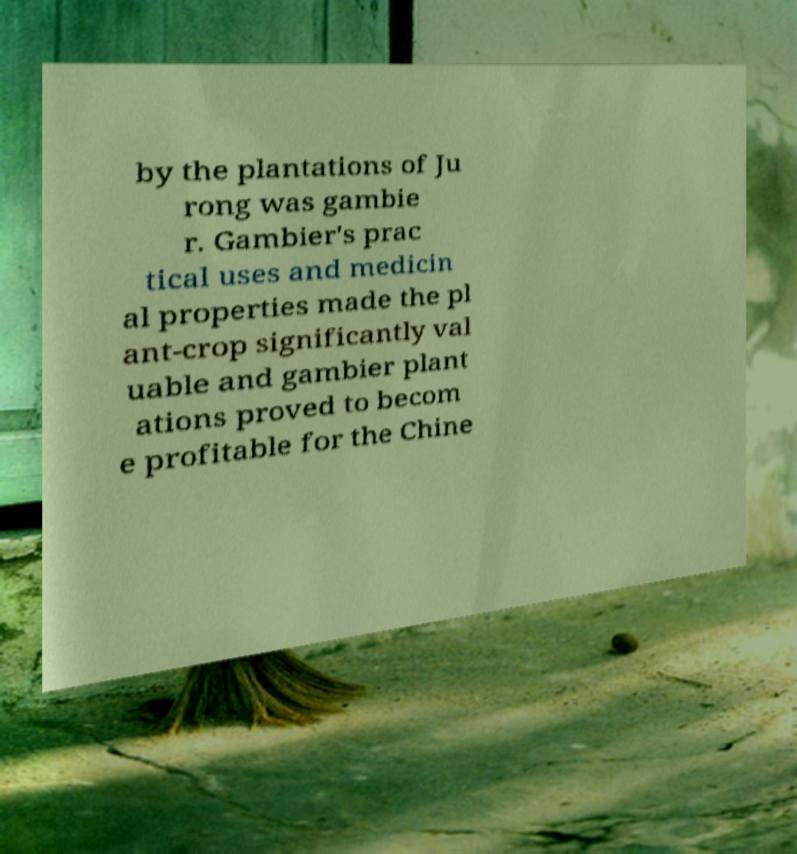Could you assist in decoding the text presented in this image and type it out clearly? by the plantations of Ju rong was gambie r. Gambier's prac tical uses and medicin al properties made the pl ant-crop significantly val uable and gambier plant ations proved to becom e profitable for the Chine 